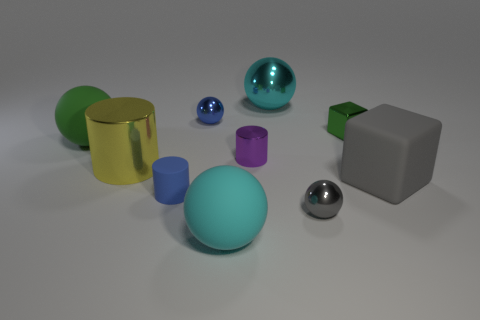There is a rubber cylinder; does it have the same color as the small metal ball behind the large green matte sphere? While the rubber cylinder and the small metal ball present unique textural qualities, with the cylinder appearing opaque and matte while the ball reflects its surroundings, they share a similar shade of blue, connecting them visually despite their distinct material properties. 